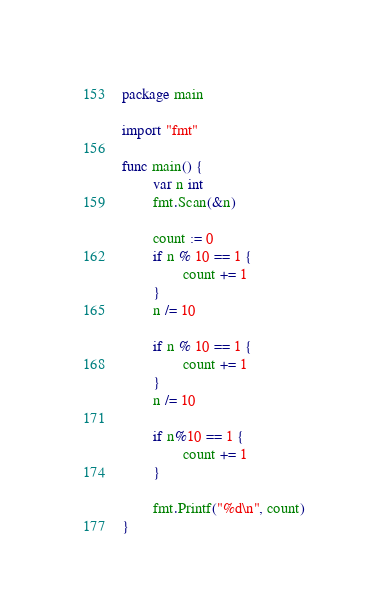Convert code to text. <code><loc_0><loc_0><loc_500><loc_500><_Go_>package main

import "fmt"

func main() {
        var n int
        fmt.Scan(&n)

        count := 0
        if n % 10 == 1 {
                count += 1
        }
        n /= 10

        if n % 10 == 1 {
                count += 1
        }
        n /= 10

        if n%10 == 1 {
                count += 1
        }

        fmt.Printf("%d\n", count)
}
</code> 